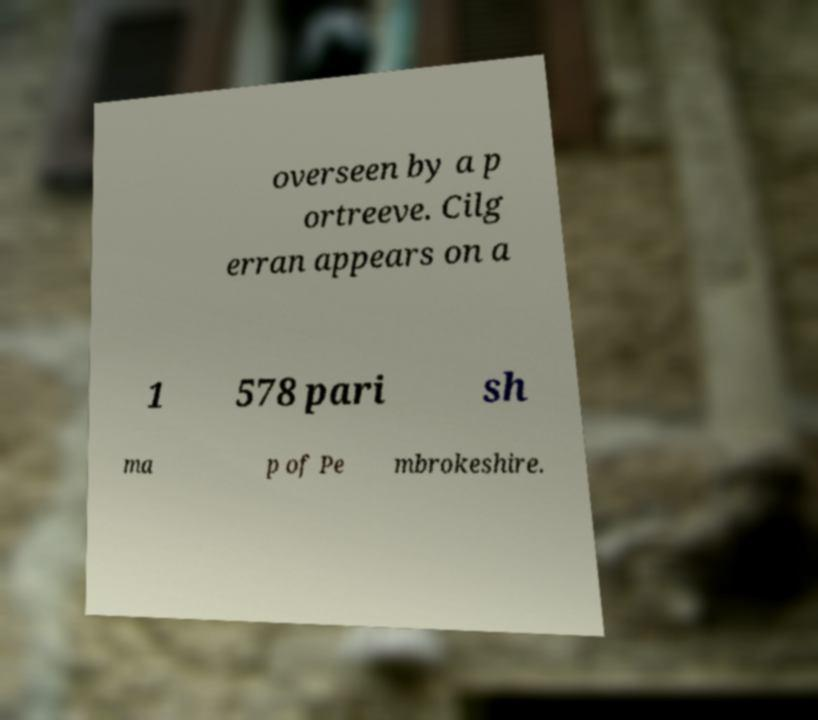Could you assist in decoding the text presented in this image and type it out clearly? overseen by a p ortreeve. Cilg erran appears on a 1 578 pari sh ma p of Pe mbrokeshire. 